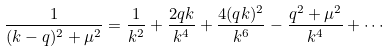Convert formula to latex. <formula><loc_0><loc_0><loc_500><loc_500>\frac { 1 } { ( k - q ) ^ { 2 } + \mu ^ { 2 } } = \frac { 1 } { k ^ { 2 } } + \frac { 2 q k } { k ^ { 4 } } + \frac { 4 ( q k ) ^ { 2 } } { k ^ { 6 } } - \frac { q ^ { 2 } + \mu ^ { 2 } } { k ^ { 4 } } + \cdots</formula> 